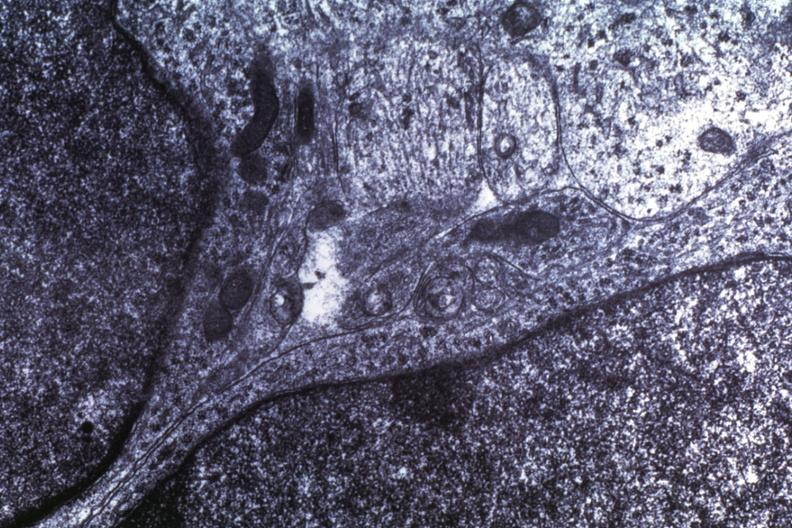what does this image show?
Answer the question using a single word or phrase. Dr garcia tumors 64 